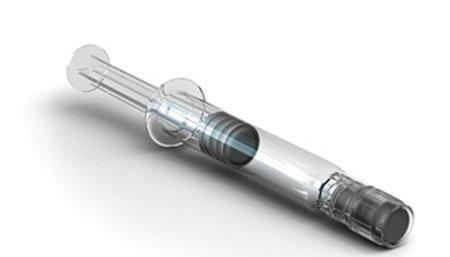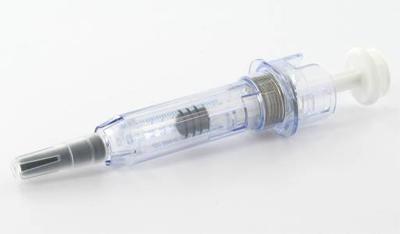The first image is the image on the left, the second image is the image on the right. Analyze the images presented: Is the assertion "In one image, the sharp end of a needle is enclosed in a cone-shaped plastic tip." valid? Answer yes or no. No. 